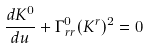Convert formula to latex. <formula><loc_0><loc_0><loc_500><loc_500>\frac { d K ^ { 0 } } { d u } + \Gamma _ { r r } ^ { 0 } ( K ^ { r } ) ^ { 2 } = 0</formula> 